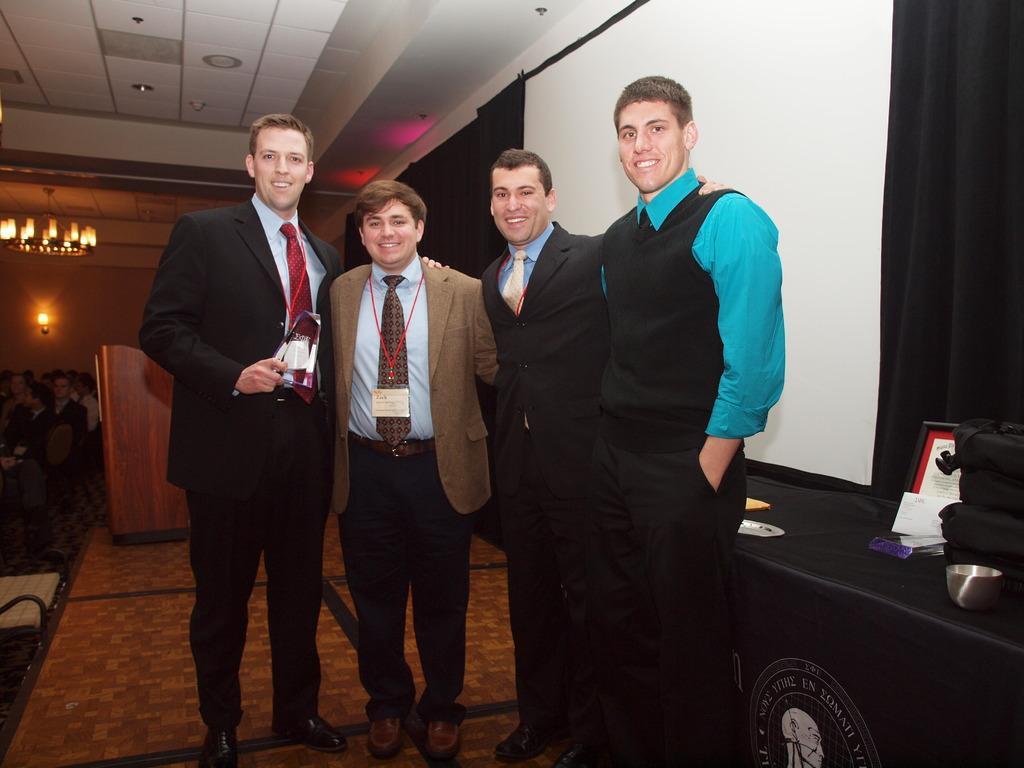Describe this image in one or two sentences. In this image I can see the group of people with different color dresses. To the right I can see the bowl, board, papers and few objects on the table. To the left I can see few more people and the podium. In the background I can see the light and the wall. I can see the chandelier at the top. 